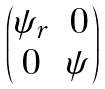Convert formula to latex. <formula><loc_0><loc_0><loc_500><loc_500>\begin{pmatrix} \psi _ { r } & 0 \\ 0 & \psi \end{pmatrix}</formula> 